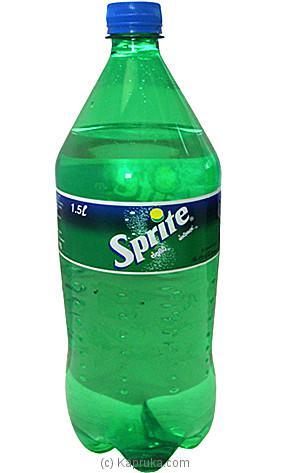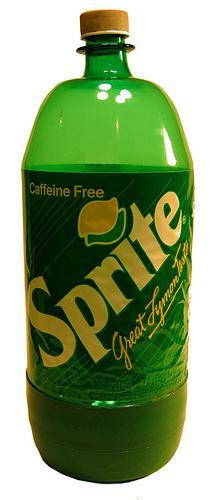The first image is the image on the left, the second image is the image on the right. Analyze the images presented: Is the assertion "All of the soda bottles are green." valid? Answer yes or no. Yes. The first image is the image on the left, the second image is the image on the right. Assess this claim about the two images: "There are two bottles total.". Correct or not? Answer yes or no. Yes. 